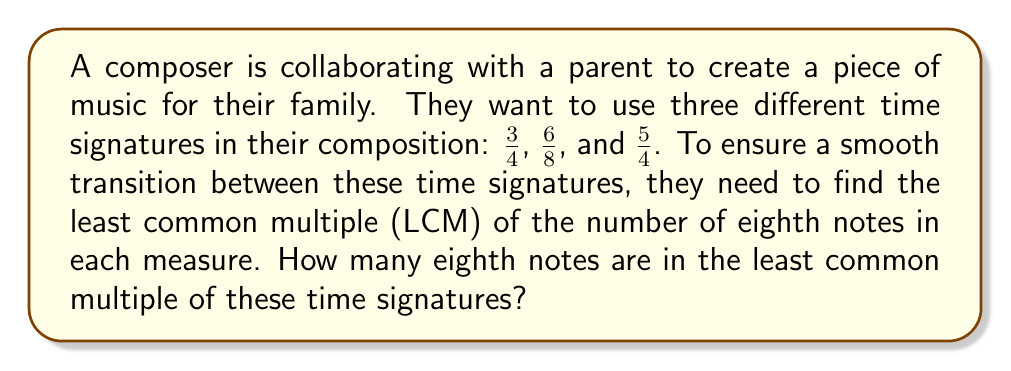Teach me how to tackle this problem. To solve this problem, we'll follow these steps:

1) First, convert each time signature to the number of eighth notes per measure:
   
   $\frac{3}{4}$ = 6 eighth notes (3 * 2)
   $\frac{6}{8}$ = 6 eighth notes
   $\frac{5}{4}$ = 10 eighth notes (5 * 2)

2) Now we need to find the LCM of 6, 6, and 10.

3) To find the LCM, let's first find the prime factorization of each number:
   
   6 = $2 * 3$
   10 = $2 * 5$

4) The LCM will include the highest power of each prime factor:
   
   LCM = $2 * 3 * 5$

5) Calculate the result:
   
   $2 * 3 * 5 = 30$

Therefore, the least common multiple of these time signatures is 30 eighth notes.
Answer: 30 eighth notes 